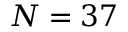<formula> <loc_0><loc_0><loc_500><loc_500>N = 3 7</formula> 